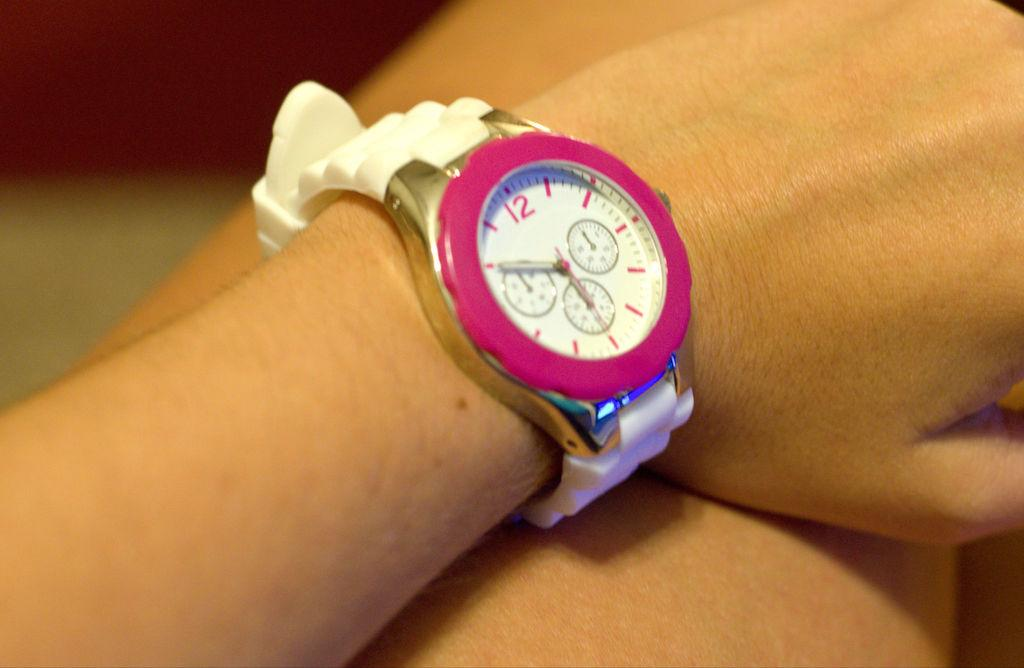<image>
Summarize the visual content of the image. A pink watch with a white face has the time of 10:30. 